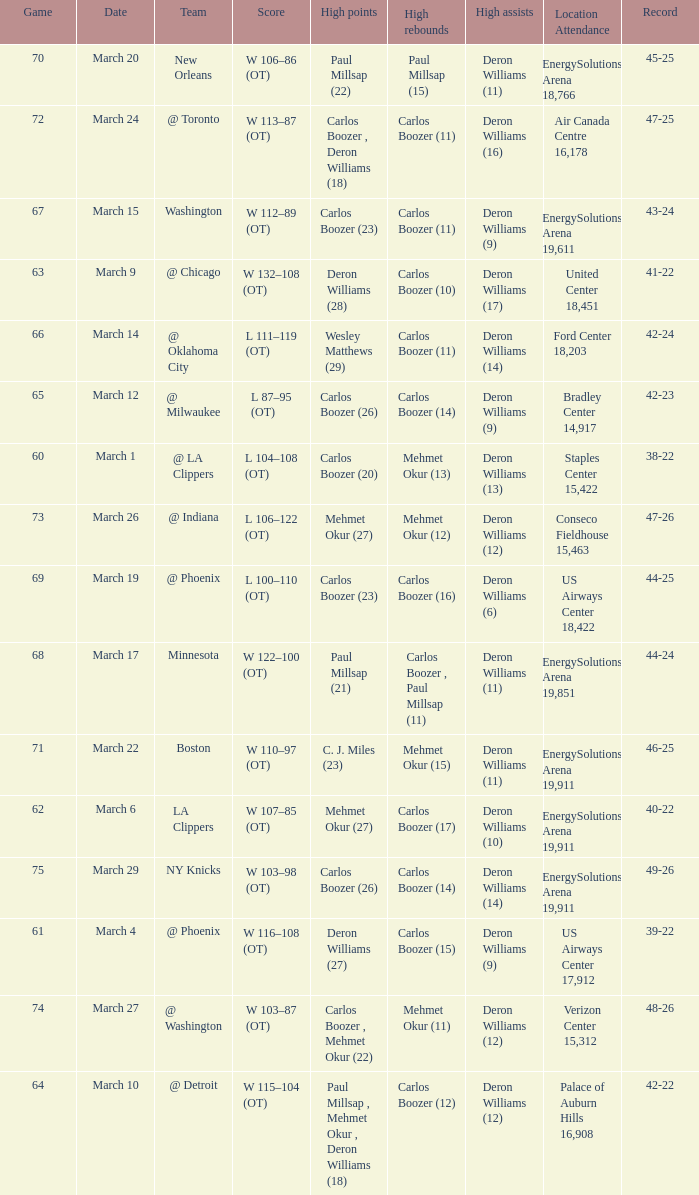What was the record at the game where Deron Williams (6) did the high assists? 44-25. 